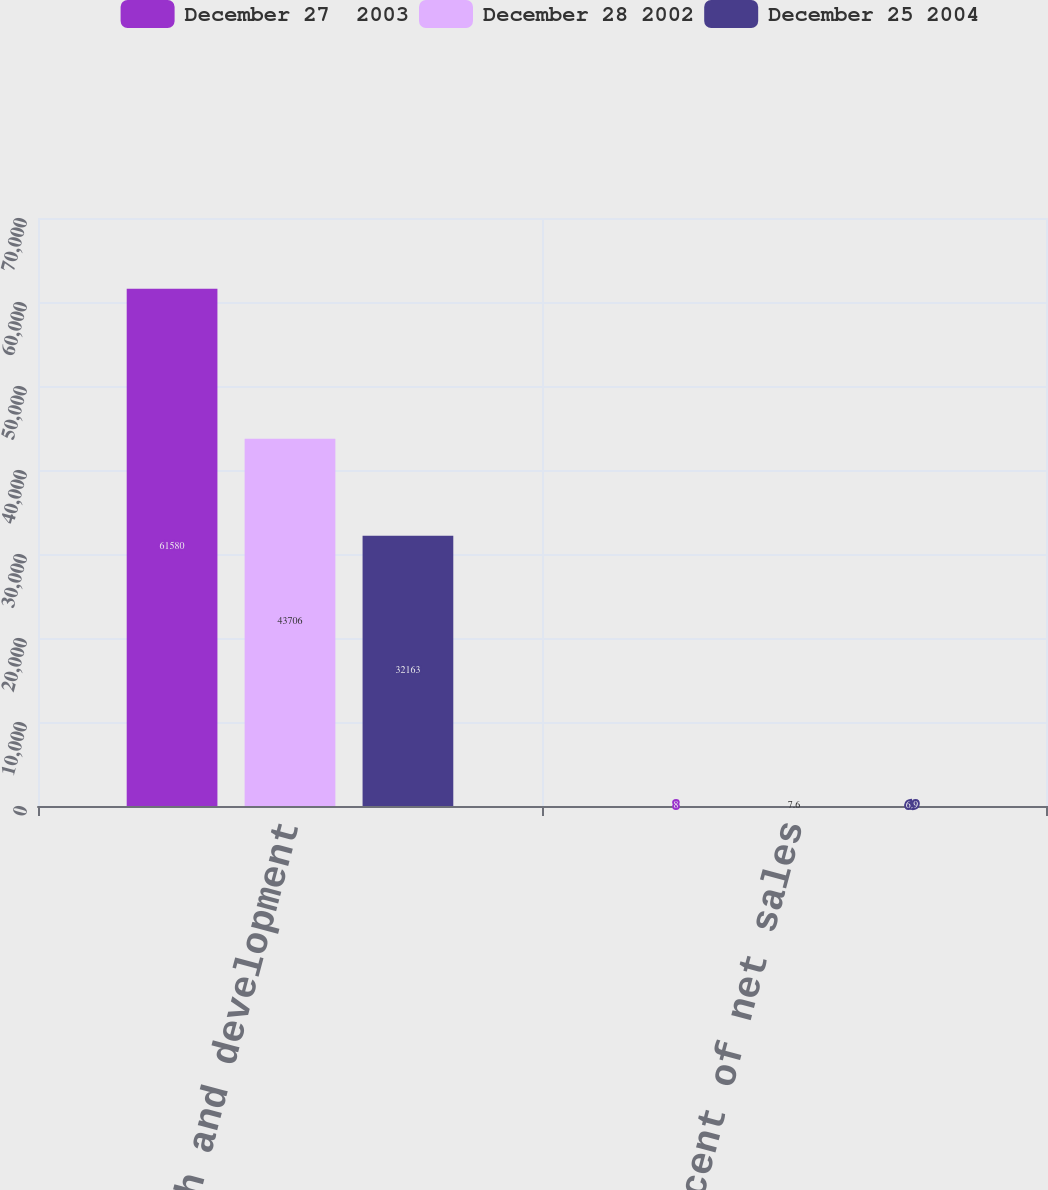<chart> <loc_0><loc_0><loc_500><loc_500><stacked_bar_chart><ecel><fcel>Research and development<fcel>Percent of net sales<nl><fcel>December 27  2003<fcel>61580<fcel>8<nl><fcel>December 28 2002<fcel>43706<fcel>7.6<nl><fcel>December 25 2004<fcel>32163<fcel>6.9<nl></chart> 